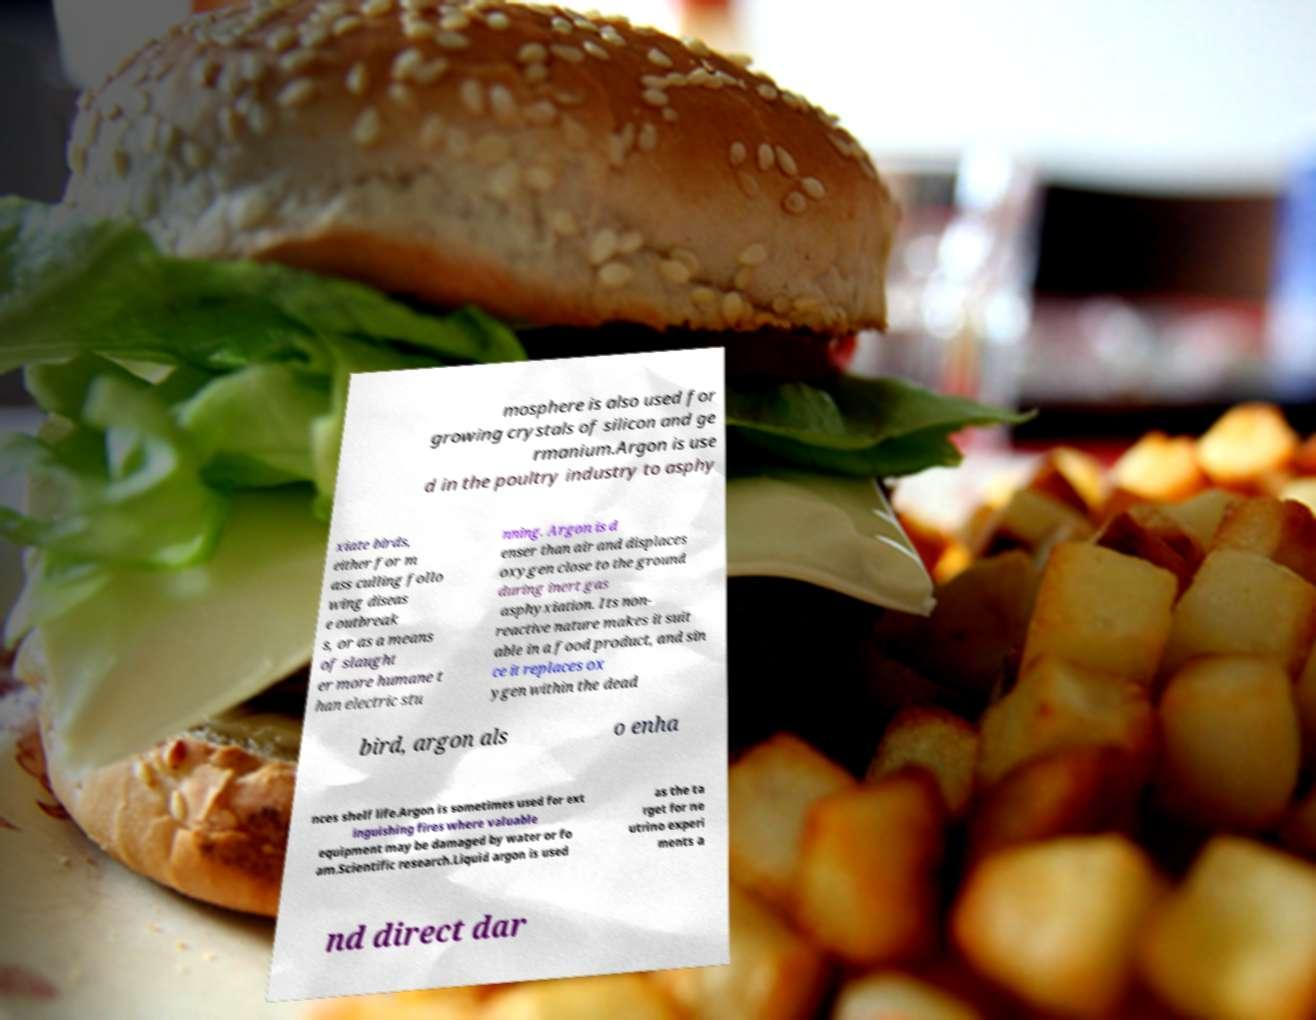Please identify and transcribe the text found in this image. mosphere is also used for growing crystals of silicon and ge rmanium.Argon is use d in the poultry industry to asphy xiate birds, either for m ass culling follo wing diseas e outbreak s, or as a means of slaught er more humane t han electric stu nning. Argon is d enser than air and displaces oxygen close to the ground during inert gas asphyxiation. Its non- reactive nature makes it suit able in a food product, and sin ce it replaces ox ygen within the dead bird, argon als o enha nces shelf life.Argon is sometimes used for ext inguishing fires where valuable equipment may be damaged by water or fo am.Scientific research.Liquid argon is used as the ta rget for ne utrino experi ments a nd direct dar 